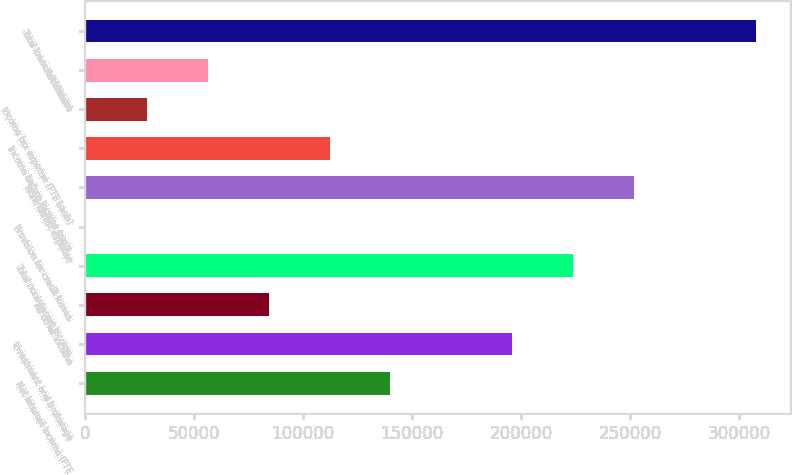Convert chart to OTSL. <chart><loc_0><loc_0><loc_500><loc_500><bar_chart><fcel>Net interest income (FTE<fcel>Investment and brokerage<fcel>All other income<fcel>Total noninterest income<fcel>Provision for credit losses<fcel>Noninterest expense<fcel>Income before income taxes<fcel>Income tax expense (FTE basis)<fcel>Net income<fcel>Total loans and leases<nl><fcel>140106<fcel>195990<fcel>84223.1<fcel>223932<fcel>398<fcel>251873<fcel>112165<fcel>28339.7<fcel>56281.4<fcel>307757<nl></chart> 